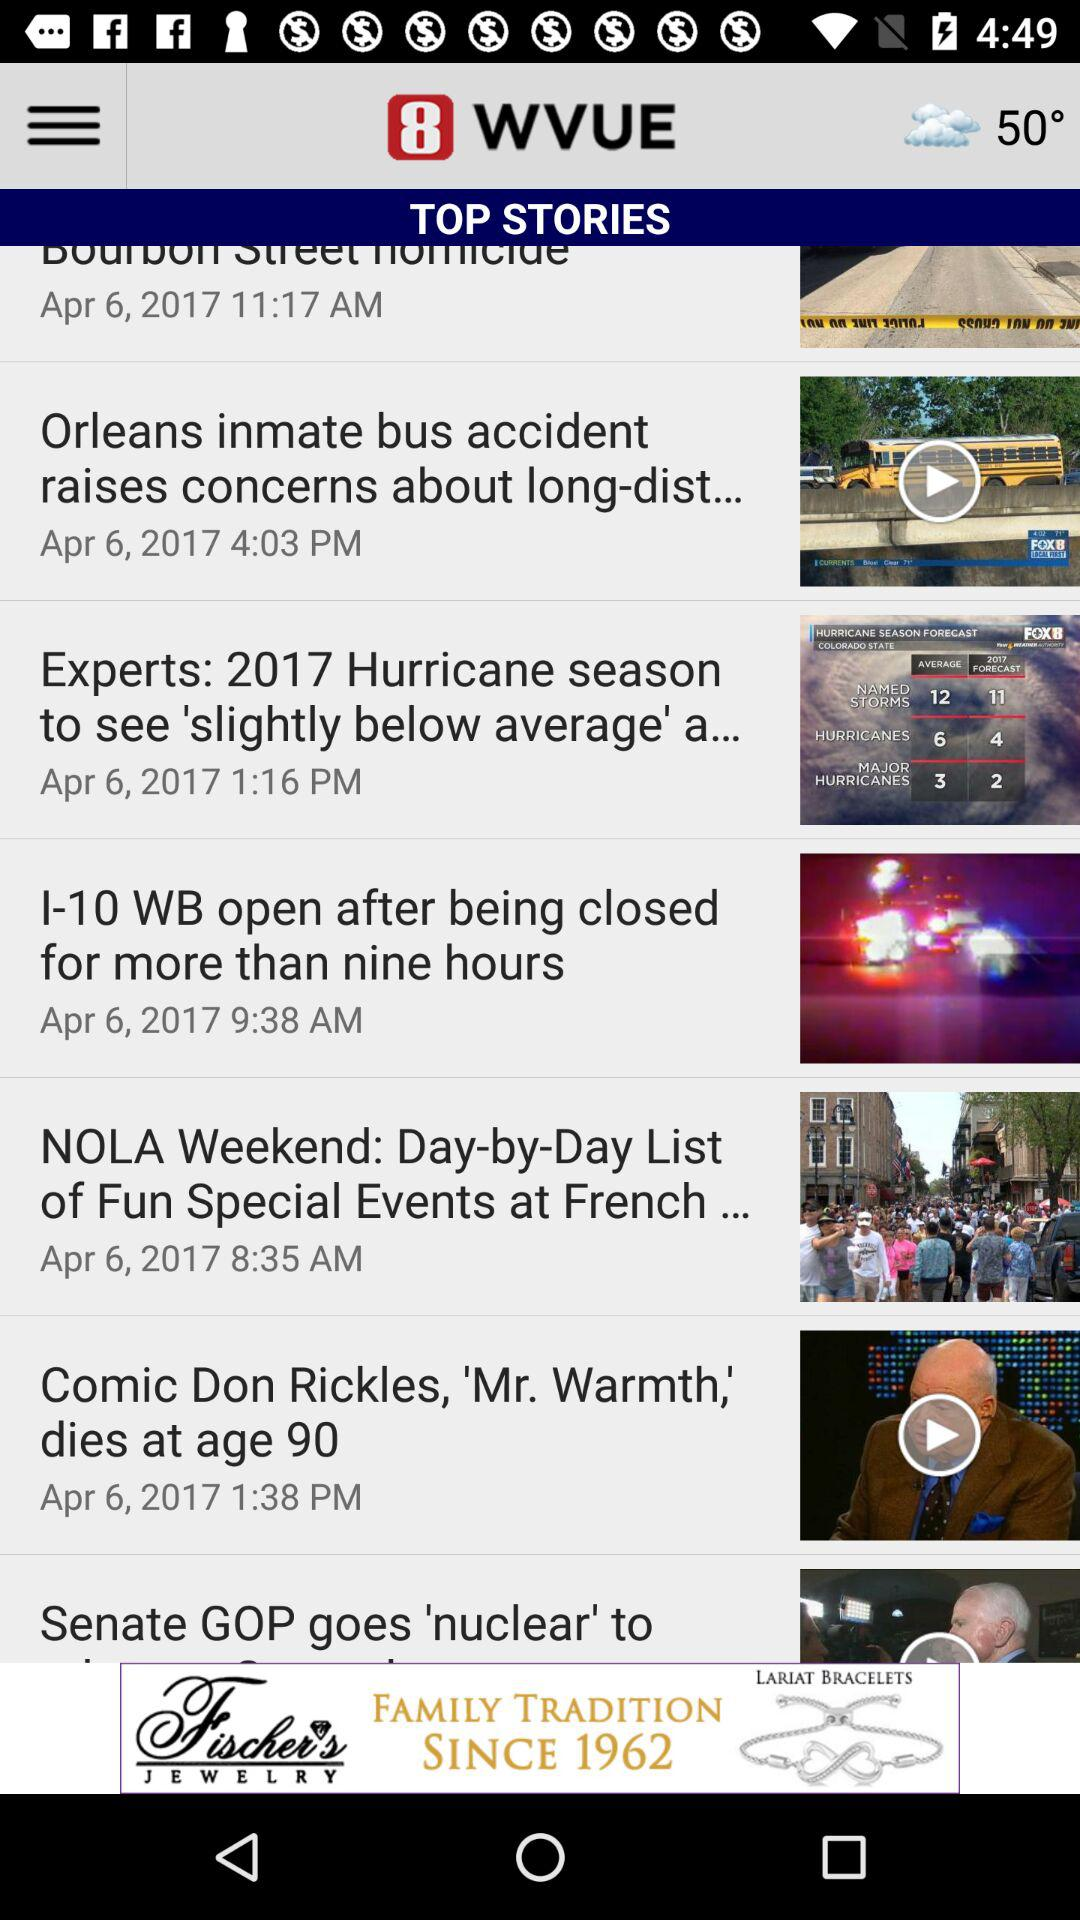What is the weather forecast? The weather is cloudy. 